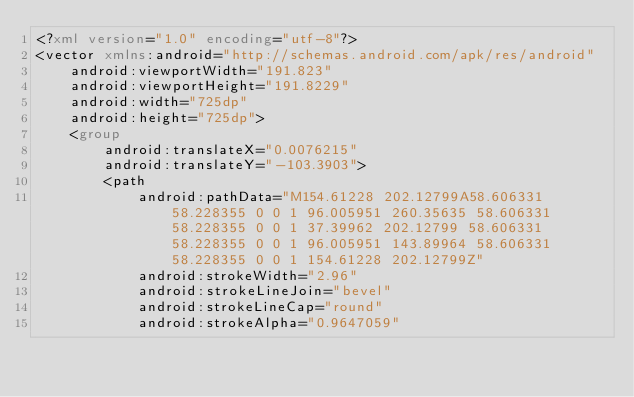Convert code to text. <code><loc_0><loc_0><loc_500><loc_500><_XML_><?xml version="1.0" encoding="utf-8"?>
<vector xmlns:android="http://schemas.android.com/apk/res/android"
    android:viewportWidth="191.823"
    android:viewportHeight="191.8229"
    android:width="725dp"
    android:height="725dp">
    <group
        android:translateX="0.0076215"
        android:translateY="-103.3903">
        <path
            android:pathData="M154.61228 202.12799A58.606331 58.228355 0 0 1 96.005951 260.35635 58.606331 58.228355 0 0 1 37.39962 202.12799 58.606331 58.228355 0 0 1 96.005951 143.89964 58.606331 58.228355 0 0 1 154.61228 202.12799Z"
            android:strokeWidth="2.96"
            android:strokeLineJoin="bevel"
            android:strokeLineCap="round"
            android:strokeAlpha="0.9647059"</code> 